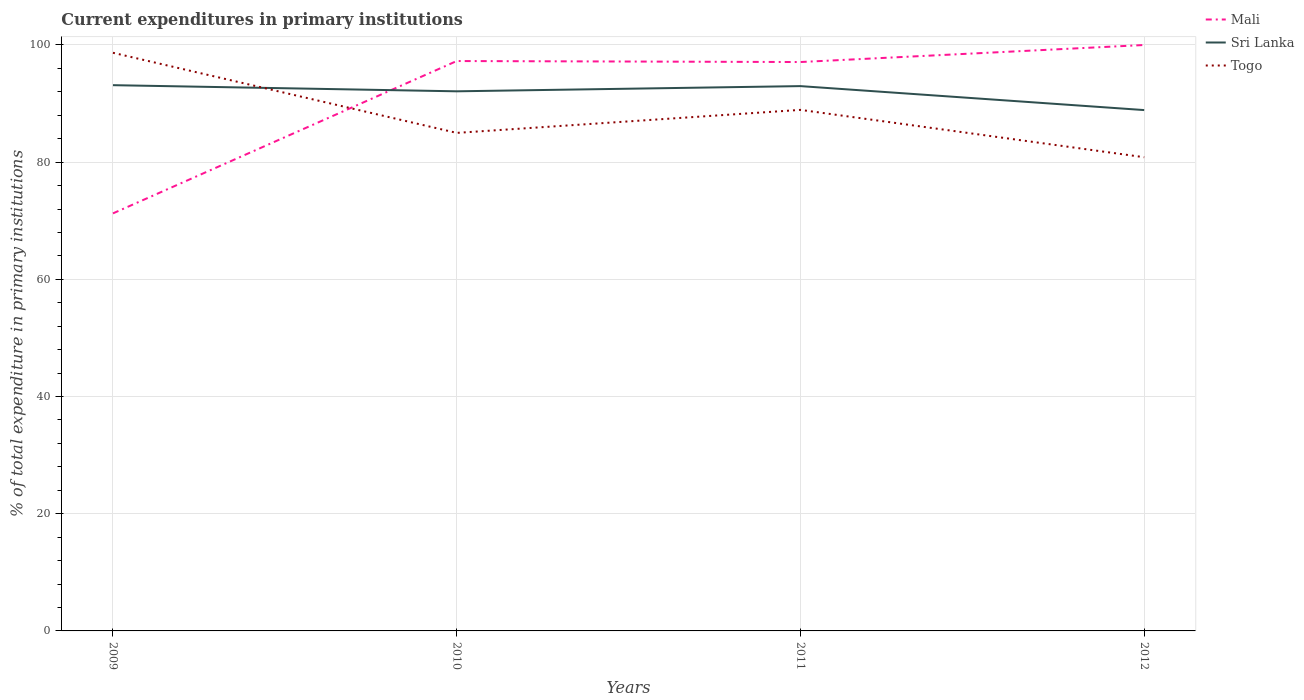How many different coloured lines are there?
Ensure brevity in your answer.  3. Across all years, what is the maximum current expenditures in primary institutions in Mali?
Your response must be concise. 71.26. What is the total current expenditures in primary institutions in Mali in the graph?
Keep it short and to the point. -26. What is the difference between the highest and the second highest current expenditures in primary institutions in Togo?
Provide a short and direct response. 17.83. How many years are there in the graph?
Your response must be concise. 4. What is the difference between two consecutive major ticks on the Y-axis?
Provide a succinct answer. 20. Does the graph contain any zero values?
Your answer should be compact. No. What is the title of the graph?
Your response must be concise. Current expenditures in primary institutions. Does "Vietnam" appear as one of the legend labels in the graph?
Your response must be concise. No. What is the label or title of the Y-axis?
Provide a succinct answer. % of total expenditure in primary institutions. What is the % of total expenditure in primary institutions of Mali in 2009?
Make the answer very short. 71.26. What is the % of total expenditure in primary institutions of Sri Lanka in 2009?
Give a very brief answer. 93.14. What is the % of total expenditure in primary institutions in Togo in 2009?
Provide a short and direct response. 98.67. What is the % of total expenditure in primary institutions in Mali in 2010?
Your response must be concise. 97.26. What is the % of total expenditure in primary institutions in Sri Lanka in 2010?
Make the answer very short. 92.09. What is the % of total expenditure in primary institutions in Togo in 2010?
Give a very brief answer. 85. What is the % of total expenditure in primary institutions of Mali in 2011?
Provide a succinct answer. 97.09. What is the % of total expenditure in primary institutions of Sri Lanka in 2011?
Keep it short and to the point. 92.98. What is the % of total expenditure in primary institutions in Togo in 2011?
Your answer should be very brief. 88.93. What is the % of total expenditure in primary institutions of Sri Lanka in 2012?
Offer a terse response. 88.89. What is the % of total expenditure in primary institutions of Togo in 2012?
Your answer should be very brief. 80.84. Across all years, what is the maximum % of total expenditure in primary institutions in Sri Lanka?
Give a very brief answer. 93.14. Across all years, what is the maximum % of total expenditure in primary institutions in Togo?
Your response must be concise. 98.67. Across all years, what is the minimum % of total expenditure in primary institutions of Mali?
Make the answer very short. 71.26. Across all years, what is the minimum % of total expenditure in primary institutions of Sri Lanka?
Your answer should be compact. 88.89. Across all years, what is the minimum % of total expenditure in primary institutions in Togo?
Your response must be concise. 80.84. What is the total % of total expenditure in primary institutions of Mali in the graph?
Offer a terse response. 365.62. What is the total % of total expenditure in primary institutions in Sri Lanka in the graph?
Provide a short and direct response. 367.11. What is the total % of total expenditure in primary institutions in Togo in the graph?
Your response must be concise. 353.44. What is the difference between the % of total expenditure in primary institutions of Mali in 2009 and that in 2010?
Make the answer very short. -26. What is the difference between the % of total expenditure in primary institutions in Sri Lanka in 2009 and that in 2010?
Keep it short and to the point. 1.05. What is the difference between the % of total expenditure in primary institutions of Togo in 2009 and that in 2010?
Your response must be concise. 13.67. What is the difference between the % of total expenditure in primary institutions in Mali in 2009 and that in 2011?
Your answer should be very brief. -25.83. What is the difference between the % of total expenditure in primary institutions of Sri Lanka in 2009 and that in 2011?
Provide a succinct answer. 0.16. What is the difference between the % of total expenditure in primary institutions in Togo in 2009 and that in 2011?
Make the answer very short. 9.74. What is the difference between the % of total expenditure in primary institutions of Mali in 2009 and that in 2012?
Keep it short and to the point. -28.74. What is the difference between the % of total expenditure in primary institutions in Sri Lanka in 2009 and that in 2012?
Provide a succinct answer. 4.25. What is the difference between the % of total expenditure in primary institutions of Togo in 2009 and that in 2012?
Offer a terse response. 17.83. What is the difference between the % of total expenditure in primary institutions of Mali in 2010 and that in 2011?
Offer a terse response. 0.17. What is the difference between the % of total expenditure in primary institutions in Sri Lanka in 2010 and that in 2011?
Offer a terse response. -0.89. What is the difference between the % of total expenditure in primary institutions in Togo in 2010 and that in 2011?
Keep it short and to the point. -3.93. What is the difference between the % of total expenditure in primary institutions of Mali in 2010 and that in 2012?
Your answer should be compact. -2.74. What is the difference between the % of total expenditure in primary institutions in Sri Lanka in 2010 and that in 2012?
Provide a short and direct response. 3.2. What is the difference between the % of total expenditure in primary institutions of Togo in 2010 and that in 2012?
Your answer should be compact. 4.15. What is the difference between the % of total expenditure in primary institutions in Mali in 2011 and that in 2012?
Your response must be concise. -2.91. What is the difference between the % of total expenditure in primary institutions of Sri Lanka in 2011 and that in 2012?
Your answer should be compact. 4.09. What is the difference between the % of total expenditure in primary institutions in Togo in 2011 and that in 2012?
Your answer should be compact. 8.08. What is the difference between the % of total expenditure in primary institutions in Mali in 2009 and the % of total expenditure in primary institutions in Sri Lanka in 2010?
Provide a succinct answer. -20.83. What is the difference between the % of total expenditure in primary institutions in Mali in 2009 and the % of total expenditure in primary institutions in Togo in 2010?
Offer a very short reply. -13.74. What is the difference between the % of total expenditure in primary institutions of Sri Lanka in 2009 and the % of total expenditure in primary institutions of Togo in 2010?
Give a very brief answer. 8.14. What is the difference between the % of total expenditure in primary institutions in Mali in 2009 and the % of total expenditure in primary institutions in Sri Lanka in 2011?
Offer a terse response. -21.72. What is the difference between the % of total expenditure in primary institutions of Mali in 2009 and the % of total expenditure in primary institutions of Togo in 2011?
Offer a terse response. -17.67. What is the difference between the % of total expenditure in primary institutions of Sri Lanka in 2009 and the % of total expenditure in primary institutions of Togo in 2011?
Your response must be concise. 4.22. What is the difference between the % of total expenditure in primary institutions of Mali in 2009 and the % of total expenditure in primary institutions of Sri Lanka in 2012?
Offer a terse response. -17.63. What is the difference between the % of total expenditure in primary institutions in Mali in 2009 and the % of total expenditure in primary institutions in Togo in 2012?
Provide a short and direct response. -9.58. What is the difference between the % of total expenditure in primary institutions of Sri Lanka in 2009 and the % of total expenditure in primary institutions of Togo in 2012?
Provide a succinct answer. 12.3. What is the difference between the % of total expenditure in primary institutions of Mali in 2010 and the % of total expenditure in primary institutions of Sri Lanka in 2011?
Provide a succinct answer. 4.28. What is the difference between the % of total expenditure in primary institutions in Mali in 2010 and the % of total expenditure in primary institutions in Togo in 2011?
Offer a very short reply. 8.34. What is the difference between the % of total expenditure in primary institutions of Sri Lanka in 2010 and the % of total expenditure in primary institutions of Togo in 2011?
Your answer should be compact. 3.17. What is the difference between the % of total expenditure in primary institutions in Mali in 2010 and the % of total expenditure in primary institutions in Sri Lanka in 2012?
Offer a terse response. 8.37. What is the difference between the % of total expenditure in primary institutions of Mali in 2010 and the % of total expenditure in primary institutions of Togo in 2012?
Your answer should be very brief. 16.42. What is the difference between the % of total expenditure in primary institutions in Sri Lanka in 2010 and the % of total expenditure in primary institutions in Togo in 2012?
Offer a very short reply. 11.25. What is the difference between the % of total expenditure in primary institutions in Mali in 2011 and the % of total expenditure in primary institutions in Sri Lanka in 2012?
Offer a terse response. 8.2. What is the difference between the % of total expenditure in primary institutions of Mali in 2011 and the % of total expenditure in primary institutions of Togo in 2012?
Give a very brief answer. 16.25. What is the difference between the % of total expenditure in primary institutions in Sri Lanka in 2011 and the % of total expenditure in primary institutions in Togo in 2012?
Your answer should be very brief. 12.14. What is the average % of total expenditure in primary institutions of Mali per year?
Make the answer very short. 91.4. What is the average % of total expenditure in primary institutions in Sri Lanka per year?
Your answer should be very brief. 91.78. What is the average % of total expenditure in primary institutions of Togo per year?
Provide a succinct answer. 88.36. In the year 2009, what is the difference between the % of total expenditure in primary institutions in Mali and % of total expenditure in primary institutions in Sri Lanka?
Make the answer very short. -21.88. In the year 2009, what is the difference between the % of total expenditure in primary institutions of Mali and % of total expenditure in primary institutions of Togo?
Provide a short and direct response. -27.41. In the year 2009, what is the difference between the % of total expenditure in primary institutions of Sri Lanka and % of total expenditure in primary institutions of Togo?
Provide a short and direct response. -5.53. In the year 2010, what is the difference between the % of total expenditure in primary institutions in Mali and % of total expenditure in primary institutions in Sri Lanka?
Provide a succinct answer. 5.17. In the year 2010, what is the difference between the % of total expenditure in primary institutions in Mali and % of total expenditure in primary institutions in Togo?
Provide a short and direct response. 12.26. In the year 2010, what is the difference between the % of total expenditure in primary institutions in Sri Lanka and % of total expenditure in primary institutions in Togo?
Your answer should be very brief. 7.1. In the year 2011, what is the difference between the % of total expenditure in primary institutions of Mali and % of total expenditure in primary institutions of Sri Lanka?
Make the answer very short. 4.11. In the year 2011, what is the difference between the % of total expenditure in primary institutions of Mali and % of total expenditure in primary institutions of Togo?
Offer a very short reply. 8.17. In the year 2011, what is the difference between the % of total expenditure in primary institutions of Sri Lanka and % of total expenditure in primary institutions of Togo?
Provide a short and direct response. 4.06. In the year 2012, what is the difference between the % of total expenditure in primary institutions in Mali and % of total expenditure in primary institutions in Sri Lanka?
Provide a short and direct response. 11.11. In the year 2012, what is the difference between the % of total expenditure in primary institutions of Mali and % of total expenditure in primary institutions of Togo?
Make the answer very short. 19.16. In the year 2012, what is the difference between the % of total expenditure in primary institutions in Sri Lanka and % of total expenditure in primary institutions in Togo?
Provide a succinct answer. 8.05. What is the ratio of the % of total expenditure in primary institutions of Mali in 2009 to that in 2010?
Keep it short and to the point. 0.73. What is the ratio of the % of total expenditure in primary institutions in Sri Lanka in 2009 to that in 2010?
Ensure brevity in your answer.  1.01. What is the ratio of the % of total expenditure in primary institutions in Togo in 2009 to that in 2010?
Make the answer very short. 1.16. What is the ratio of the % of total expenditure in primary institutions of Mali in 2009 to that in 2011?
Offer a terse response. 0.73. What is the ratio of the % of total expenditure in primary institutions in Togo in 2009 to that in 2011?
Your response must be concise. 1.11. What is the ratio of the % of total expenditure in primary institutions of Mali in 2009 to that in 2012?
Your answer should be very brief. 0.71. What is the ratio of the % of total expenditure in primary institutions of Sri Lanka in 2009 to that in 2012?
Ensure brevity in your answer.  1.05. What is the ratio of the % of total expenditure in primary institutions of Togo in 2009 to that in 2012?
Ensure brevity in your answer.  1.22. What is the ratio of the % of total expenditure in primary institutions of Togo in 2010 to that in 2011?
Provide a short and direct response. 0.96. What is the ratio of the % of total expenditure in primary institutions in Mali in 2010 to that in 2012?
Your answer should be very brief. 0.97. What is the ratio of the % of total expenditure in primary institutions of Sri Lanka in 2010 to that in 2012?
Give a very brief answer. 1.04. What is the ratio of the % of total expenditure in primary institutions in Togo in 2010 to that in 2012?
Provide a short and direct response. 1.05. What is the ratio of the % of total expenditure in primary institutions of Mali in 2011 to that in 2012?
Keep it short and to the point. 0.97. What is the ratio of the % of total expenditure in primary institutions in Sri Lanka in 2011 to that in 2012?
Your response must be concise. 1.05. What is the difference between the highest and the second highest % of total expenditure in primary institutions in Mali?
Provide a succinct answer. 2.74. What is the difference between the highest and the second highest % of total expenditure in primary institutions of Sri Lanka?
Make the answer very short. 0.16. What is the difference between the highest and the second highest % of total expenditure in primary institutions of Togo?
Your response must be concise. 9.74. What is the difference between the highest and the lowest % of total expenditure in primary institutions of Mali?
Your response must be concise. 28.74. What is the difference between the highest and the lowest % of total expenditure in primary institutions in Sri Lanka?
Your answer should be compact. 4.25. What is the difference between the highest and the lowest % of total expenditure in primary institutions of Togo?
Offer a terse response. 17.83. 